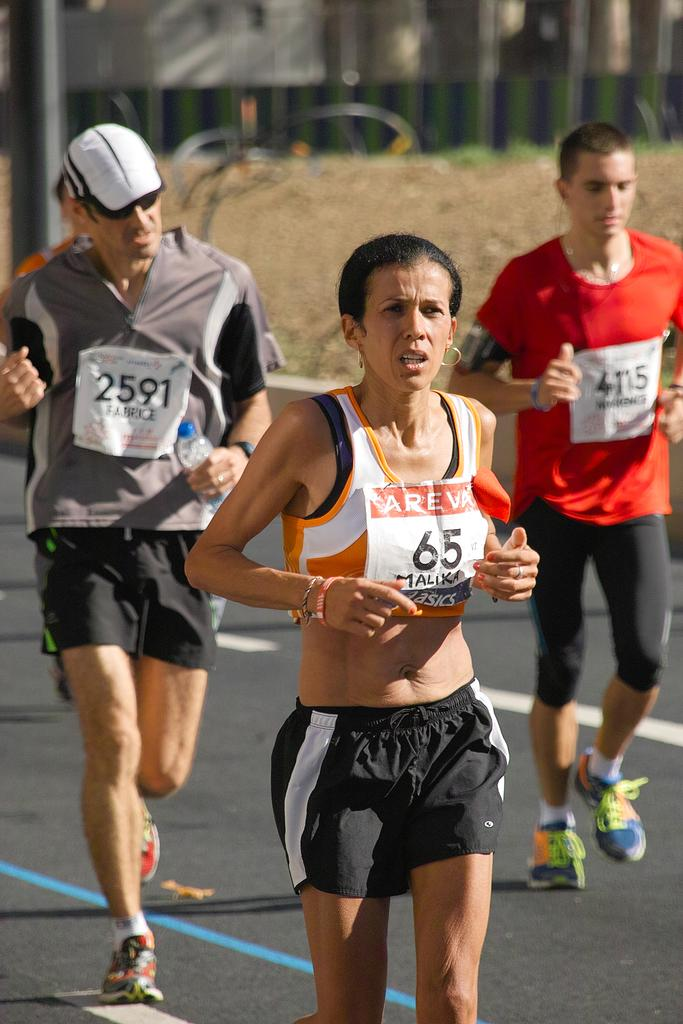<image>
Describe the image concisely. A woman named Malika wearing a 65 on her running bib. 